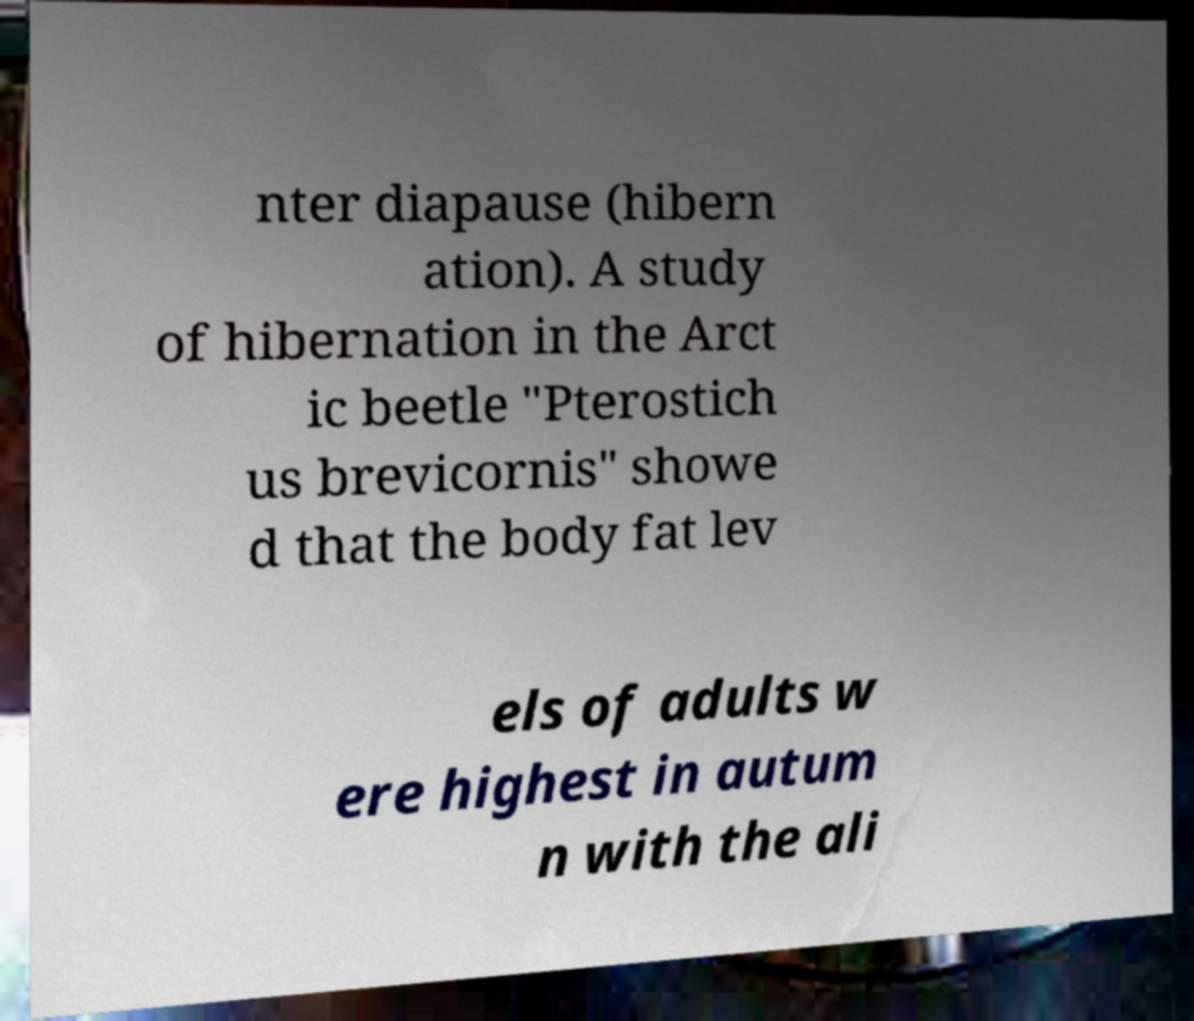Could you assist in decoding the text presented in this image and type it out clearly? nter diapause (hibern ation). A study of hibernation in the Arct ic beetle "Pterostich us brevicornis" showe d that the body fat lev els of adults w ere highest in autum n with the ali 